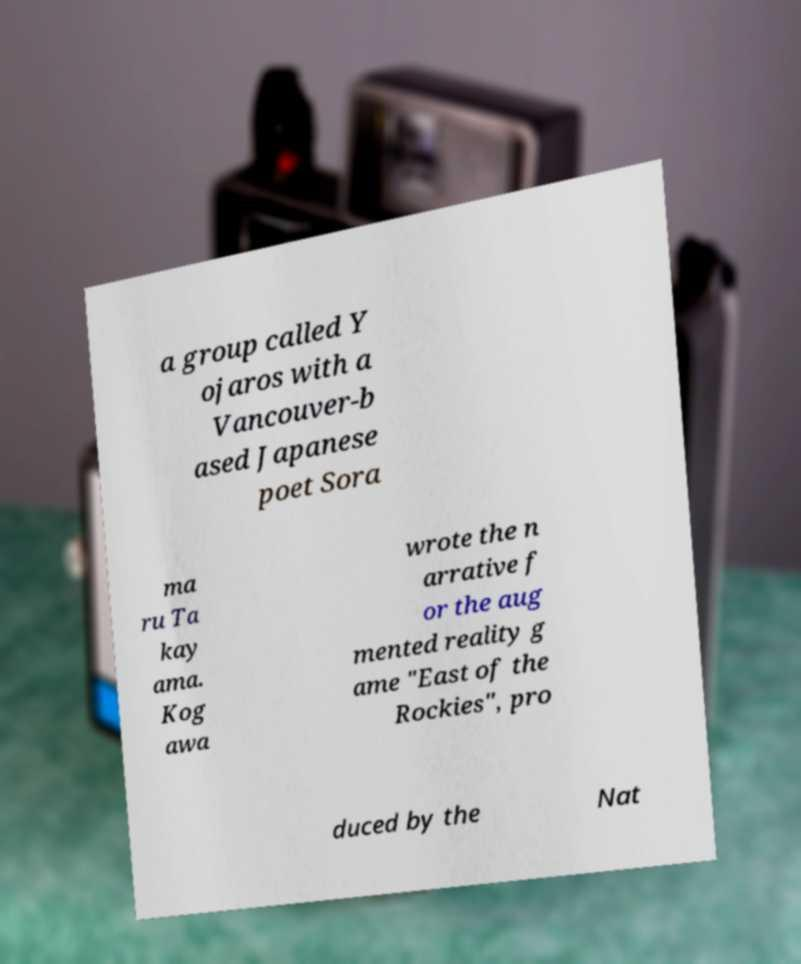Could you extract and type out the text from this image? a group called Y ojaros with a Vancouver-b ased Japanese poet Sora ma ru Ta kay ama. Kog awa wrote the n arrative f or the aug mented reality g ame "East of the Rockies", pro duced by the Nat 